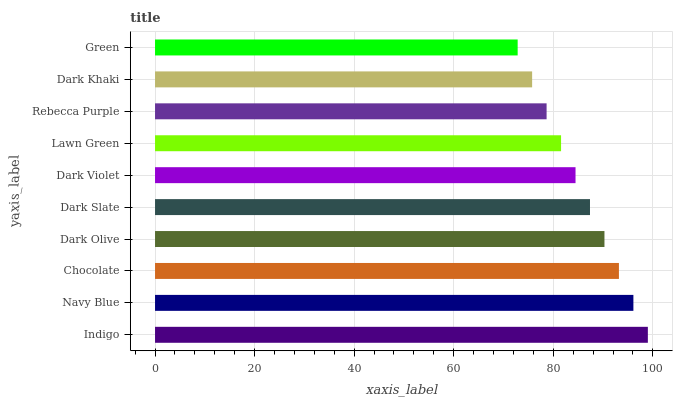Is Green the minimum?
Answer yes or no. Yes. Is Indigo the maximum?
Answer yes or no. Yes. Is Navy Blue the minimum?
Answer yes or no. No. Is Navy Blue the maximum?
Answer yes or no. No. Is Indigo greater than Navy Blue?
Answer yes or no. Yes. Is Navy Blue less than Indigo?
Answer yes or no. Yes. Is Navy Blue greater than Indigo?
Answer yes or no. No. Is Indigo less than Navy Blue?
Answer yes or no. No. Is Dark Slate the high median?
Answer yes or no. Yes. Is Dark Violet the low median?
Answer yes or no. Yes. Is Dark Olive the high median?
Answer yes or no. No. Is Chocolate the low median?
Answer yes or no. No. 